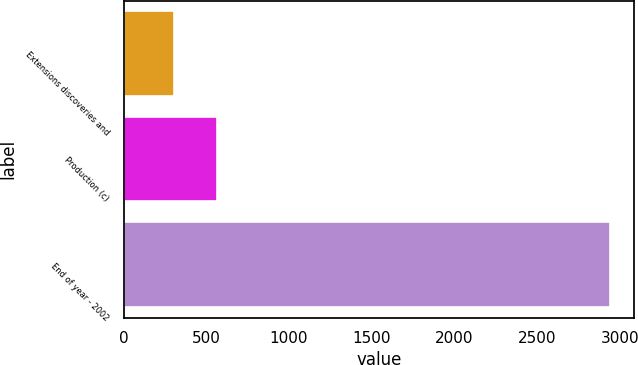Convert chart. <chart><loc_0><loc_0><loc_500><loc_500><bar_chart><fcel>Extensions discoveries and<fcel>Production (c)<fcel>End of year - 2002<nl><fcel>303<fcel>566.6<fcel>2939<nl></chart> 